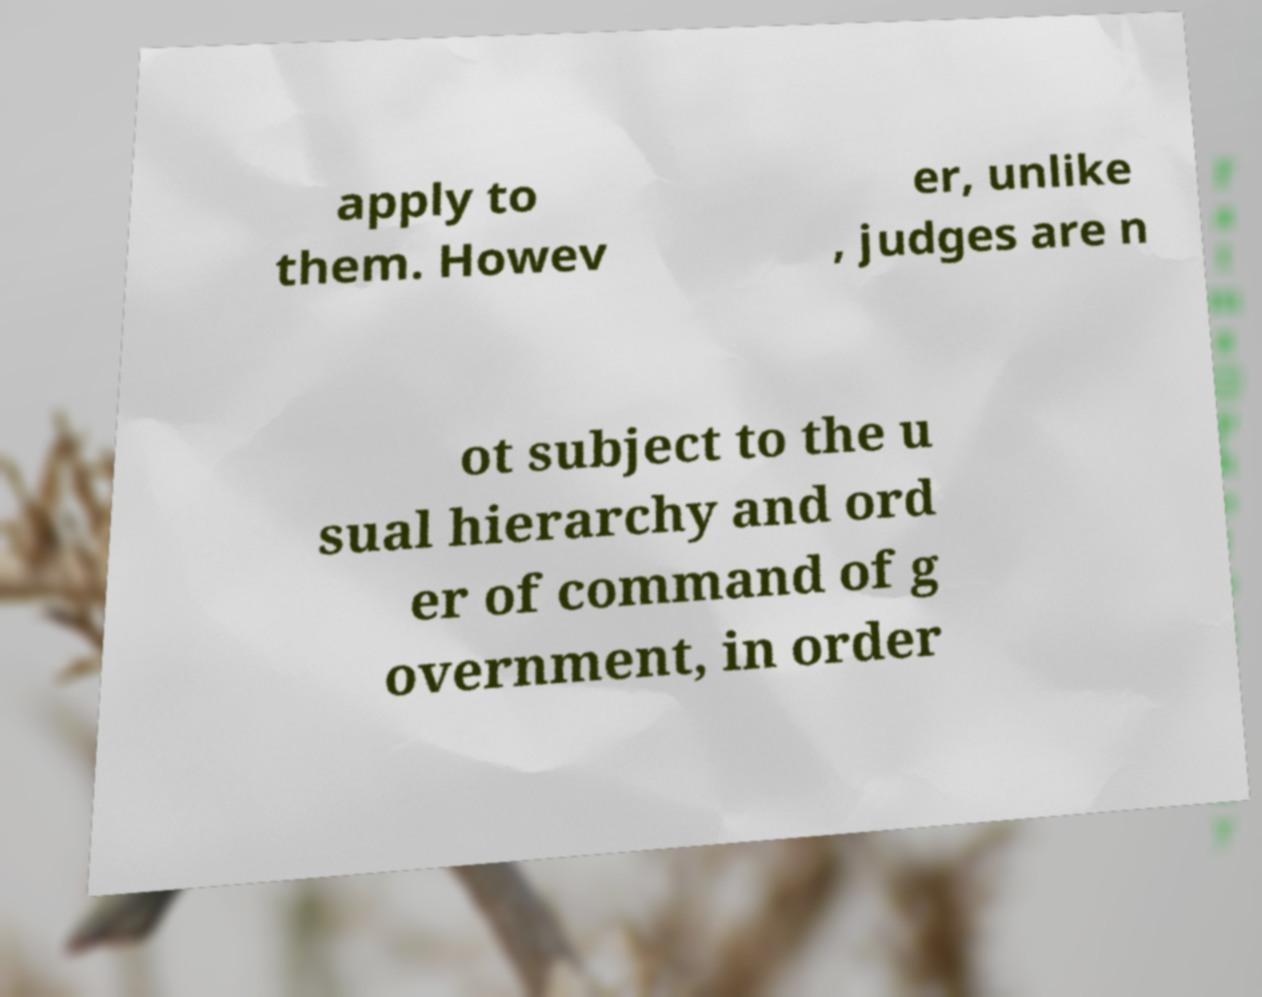What messages or text are displayed in this image? I need them in a readable, typed format. apply to them. Howev er, unlike , judges are n ot subject to the u sual hierarchy and ord er of command of g overnment, in order 